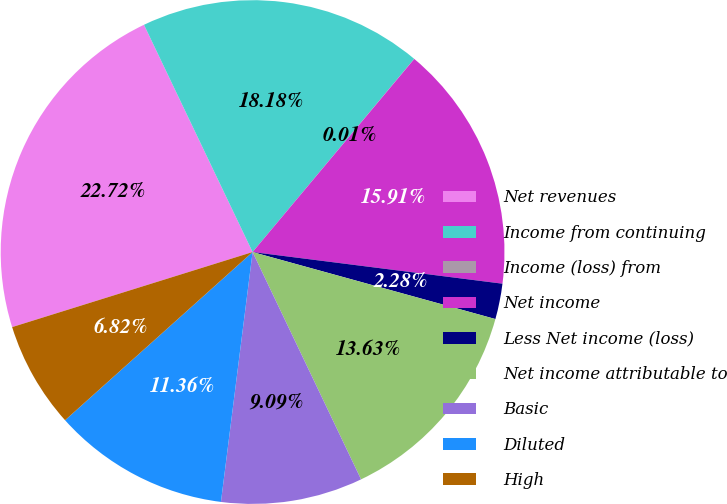<chart> <loc_0><loc_0><loc_500><loc_500><pie_chart><fcel>Net revenues<fcel>Income from continuing<fcel>Income (loss) from<fcel>Net income<fcel>Less Net income (loss)<fcel>Net income attributable to<fcel>Basic<fcel>Diluted<fcel>High<nl><fcel>22.72%<fcel>18.18%<fcel>0.01%<fcel>15.91%<fcel>2.28%<fcel>13.63%<fcel>9.09%<fcel>11.36%<fcel>6.82%<nl></chart> 